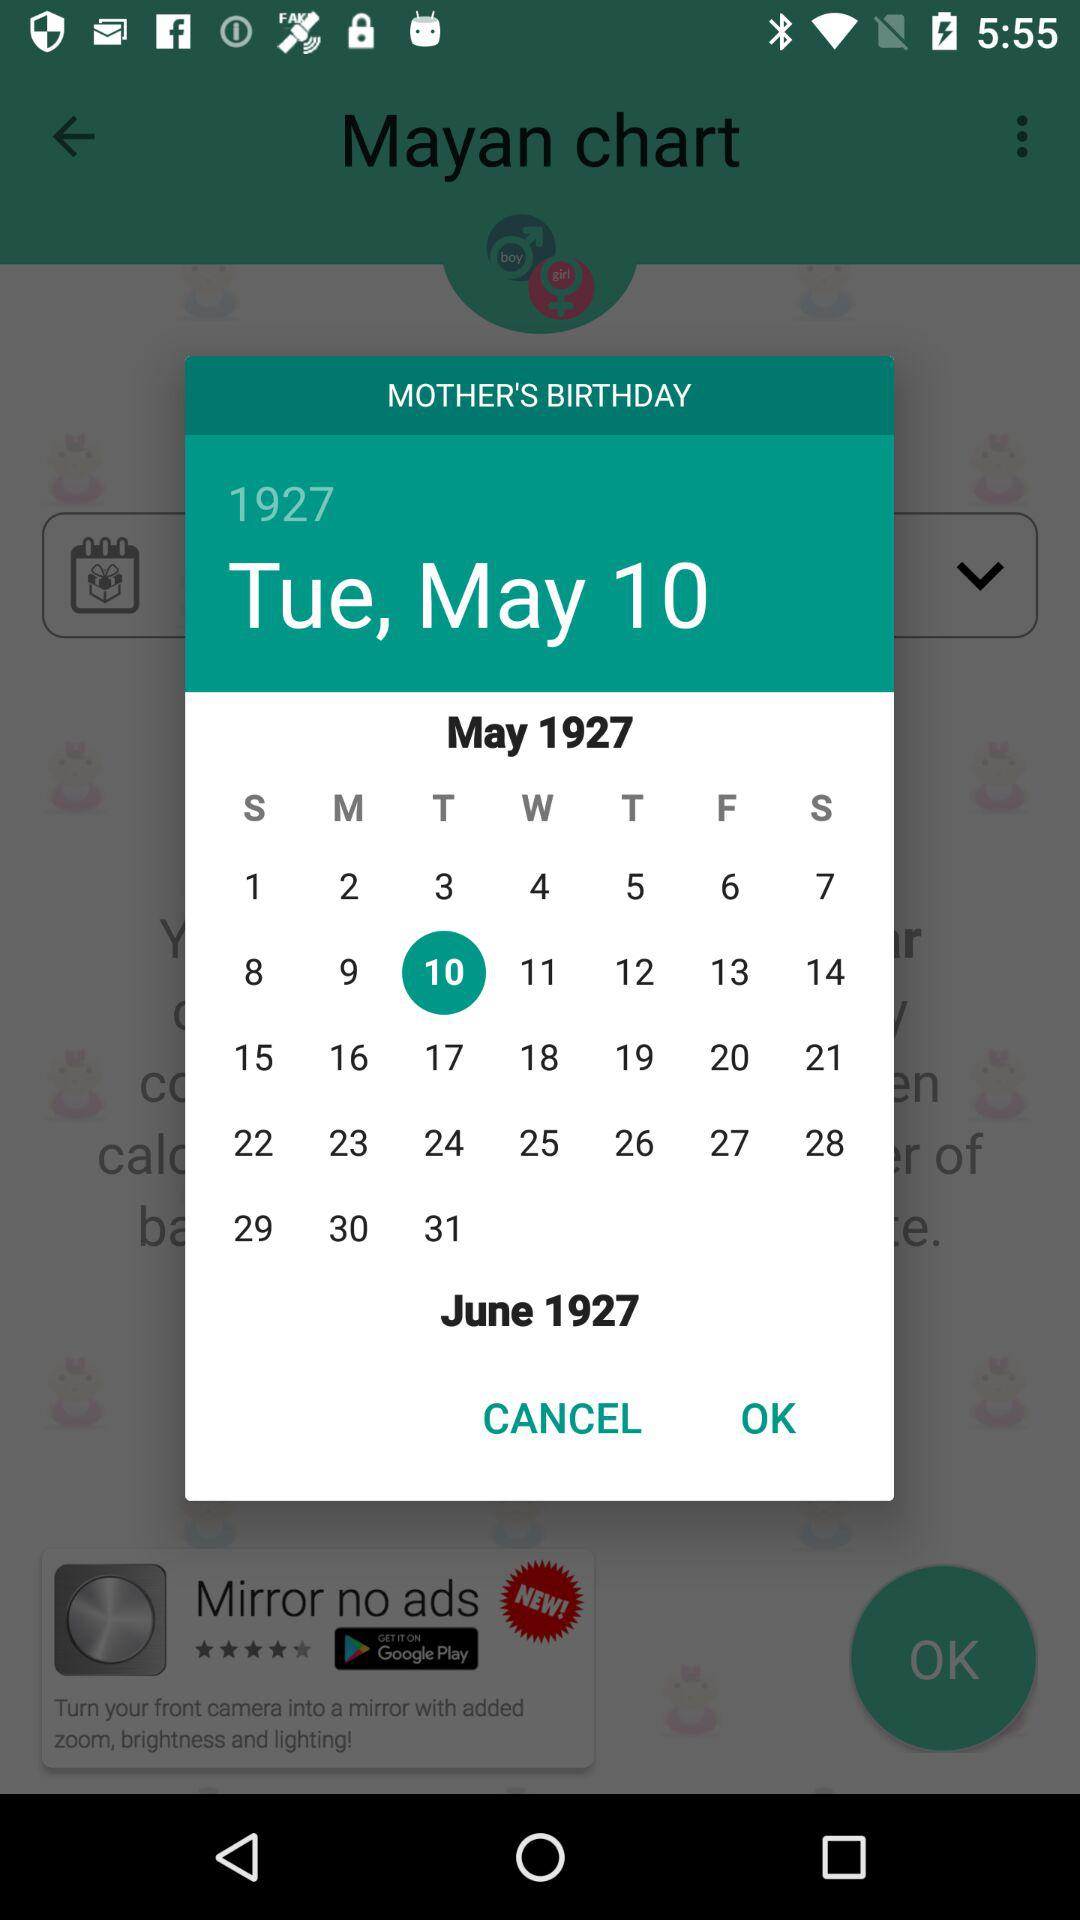What day is May 1, 1927? The day is Sunday. 